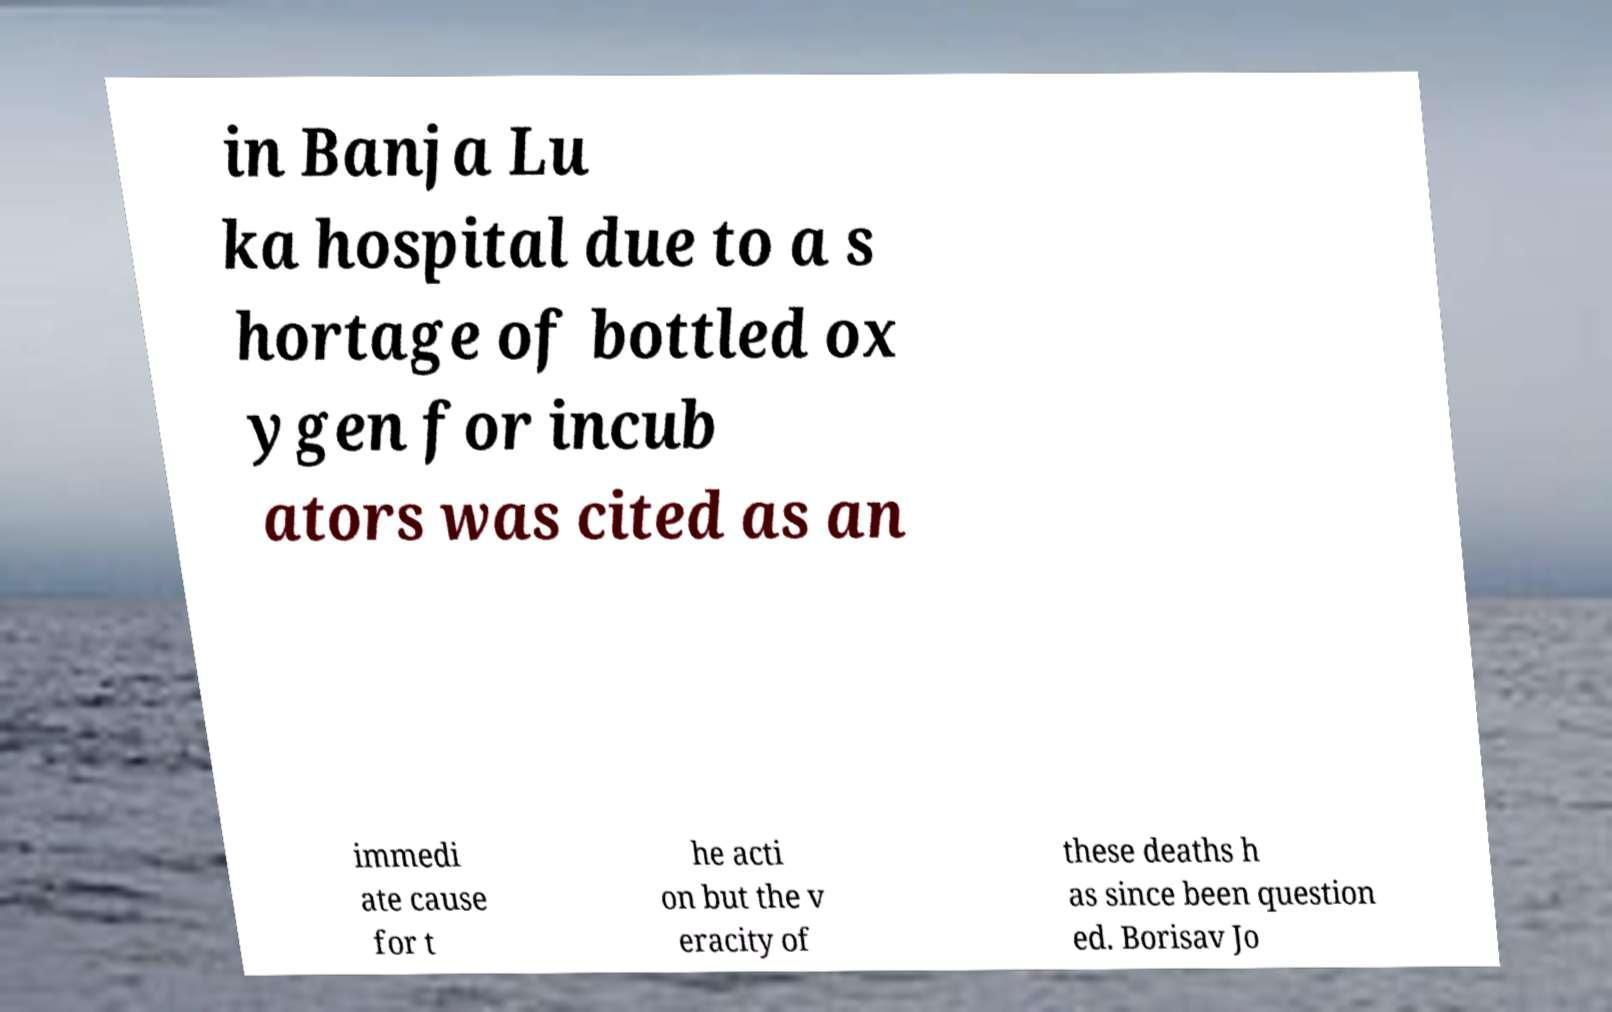I need the written content from this picture converted into text. Can you do that? in Banja Lu ka hospital due to a s hortage of bottled ox ygen for incub ators was cited as an immedi ate cause for t he acti on but the v eracity of these deaths h as since been question ed. Borisav Jo 